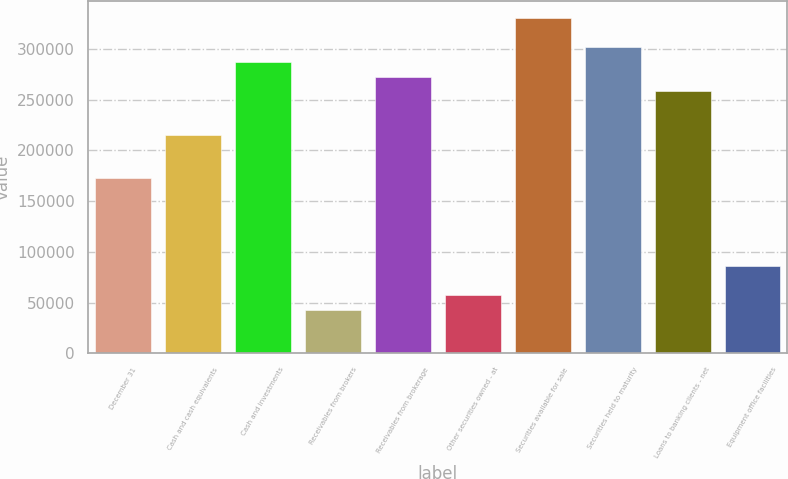Convert chart. <chart><loc_0><loc_0><loc_500><loc_500><bar_chart><fcel>December 31<fcel>Cash and cash equivalents<fcel>Cash and investments<fcel>Receivables from brokers<fcel>Receivables from brokerage<fcel>Other securities owned - at<fcel>Securities available for sale<fcel>Securities held to maturity<fcel>Loans to banking clients - net<fcel>Equipment office facilities<nl><fcel>172369<fcel>215458<fcel>287275<fcel>43098.9<fcel>272912<fcel>57462.2<fcel>330365<fcel>301638<fcel>258548<fcel>86188.8<nl></chart> 